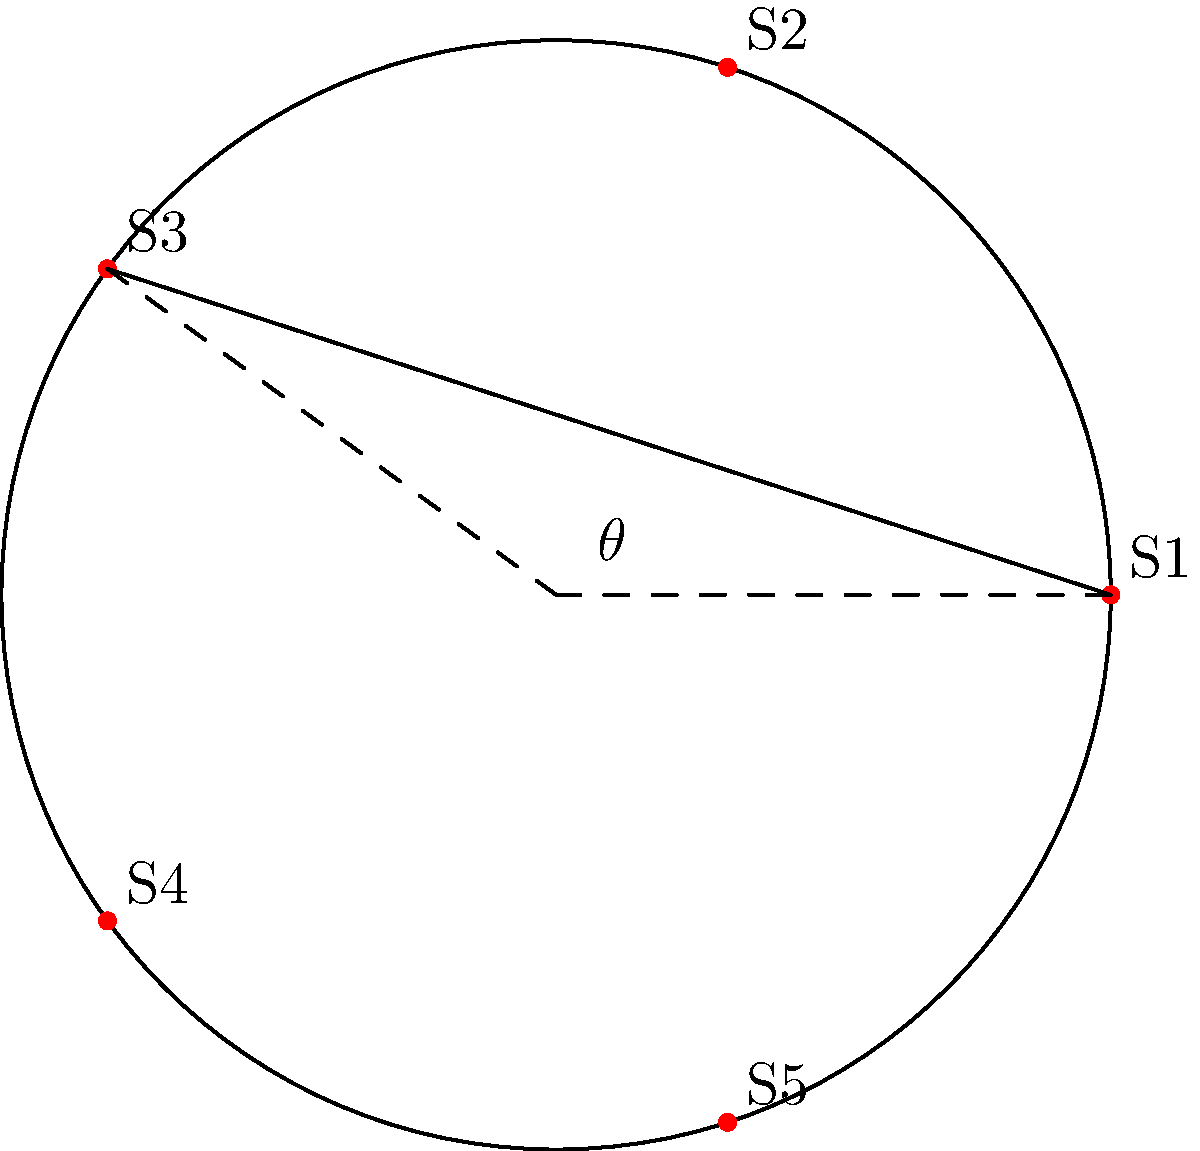In a circular storytelling arrangement, five storytellers (S1 to S5) are equally spaced around the circle. If the angle between the lines connecting the center to S1 and S3 is $\theta$, what is the value of $\theta$ in degrees? To solve this problem, let's follow these steps:

1. Recognize that the storytellers are equally spaced around the circle. This means they form a regular pentagon.

2. In a regular pentagon, the central angle between any two adjacent vertices is:
   $$\frac{360°}{5} = 72°$$

3. The angle $\theta$ in the question is formed by skipping one storyteller (S2) and connecting S1 and S3.

4. Therefore, $\theta$ is twice the central angle between adjacent storytellers:
   $$\theta = 2 \times 72° = 144°$$

5. We can verify this by noting that in a regular pentagon, the central angle between any two non-adjacent vertices that skip one vertex is always $144°$.

Thus, the angle $\theta$ between the lines connecting the center to S1 and S3 is $144°$.
Answer: 144° 